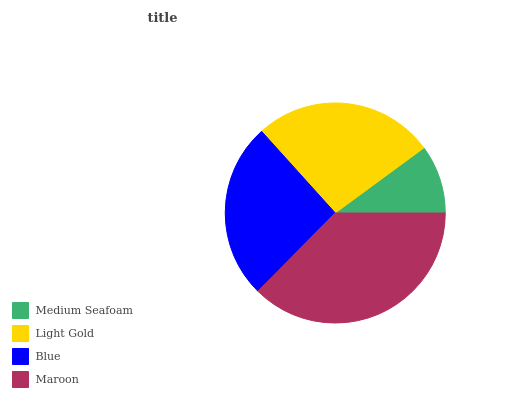Is Medium Seafoam the minimum?
Answer yes or no. Yes. Is Maroon the maximum?
Answer yes or no. Yes. Is Light Gold the minimum?
Answer yes or no. No. Is Light Gold the maximum?
Answer yes or no. No. Is Light Gold greater than Medium Seafoam?
Answer yes or no. Yes. Is Medium Seafoam less than Light Gold?
Answer yes or no. Yes. Is Medium Seafoam greater than Light Gold?
Answer yes or no. No. Is Light Gold less than Medium Seafoam?
Answer yes or no. No. Is Light Gold the high median?
Answer yes or no. Yes. Is Blue the low median?
Answer yes or no. Yes. Is Maroon the high median?
Answer yes or no. No. Is Medium Seafoam the low median?
Answer yes or no. No. 